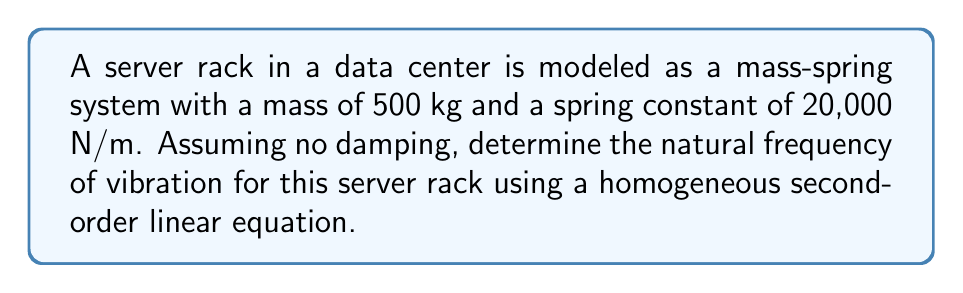Could you help me with this problem? To solve this problem, we'll follow these steps:

1) The homogeneous second-order linear equation for a mass-spring system without damping is:

   $$m\frac{d^2x}{dt^2} + kx = 0$$

   where $m$ is the mass, $k$ is the spring constant, and $x$ is the displacement.

2) The general solution to this equation is:

   $$x(t) = A\cos(\omega_n t) + B\sin(\omega_n t)$$

   where $\omega_n$ is the natural angular frequency.

3) The natural angular frequency $\omega_n$ is related to the mass and spring constant by:

   $$\omega_n = \sqrt{\frac{k}{m}}$$

4) Substituting the given values:
   $m = 500$ kg
   $k = 20,000$ N/m

   $$\omega_n = \sqrt{\frac{20,000}{500}} = \sqrt{40} = 6.32 \text{ rad/s}$$

5) The natural frequency $f_n$ in Hz is related to the angular frequency by:

   $$f_n = \frac{\omega_n}{2\pi}$$

6) Calculate the natural frequency:

   $$f_n = \frac{6.32}{2\pi} \approx 1.01 \text{ Hz}$$
Answer: The natural frequency of vibration for the server rack is approximately 1.01 Hz. 